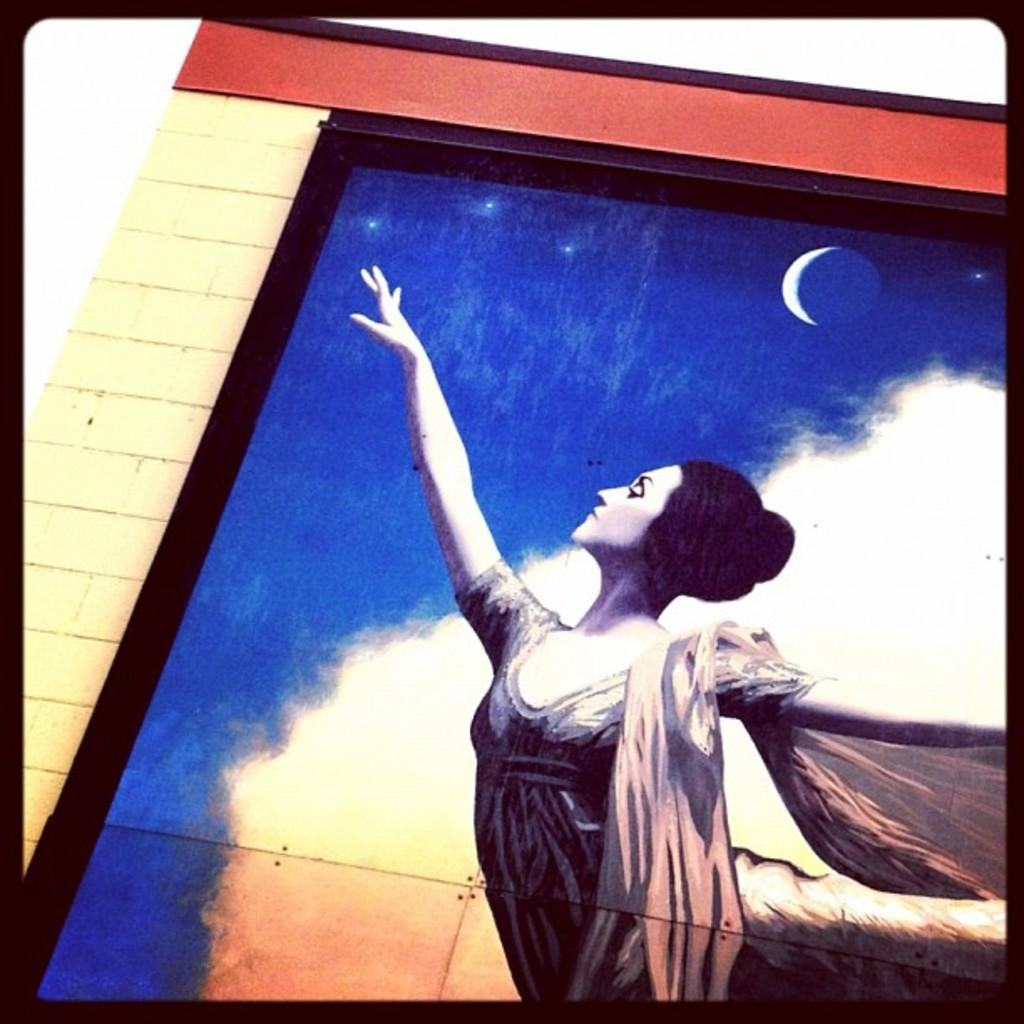What is the main subject of the image? There is a picture in the image. What is happening in the picture? The picture contains a woman standing. What can be seen at the top of the picture? There is a white color half moon at the top of the picture. What type of structure is visible in the image? There is a brick wall visible in the image. Can you tell me the total amount on the receipt in the image? There is no receipt present in the image; it contains a picture of a woman standing with a white color half moon at the top and a brick wall visible in the background. 